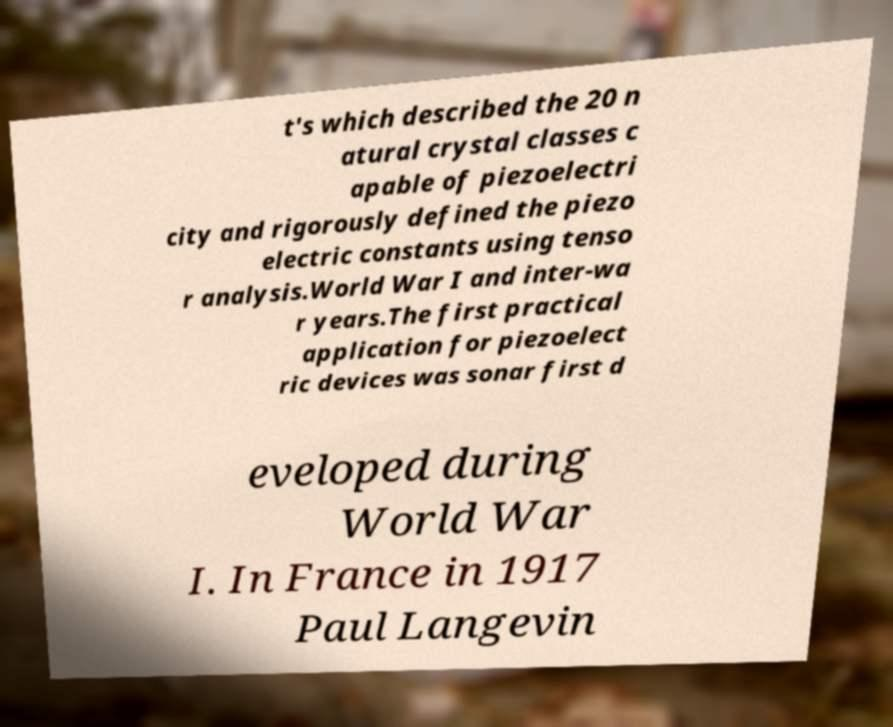For documentation purposes, I need the text within this image transcribed. Could you provide that? t's which described the 20 n atural crystal classes c apable of piezoelectri city and rigorously defined the piezo electric constants using tenso r analysis.World War I and inter-wa r years.The first practical application for piezoelect ric devices was sonar first d eveloped during World War I. In France in 1917 Paul Langevin 